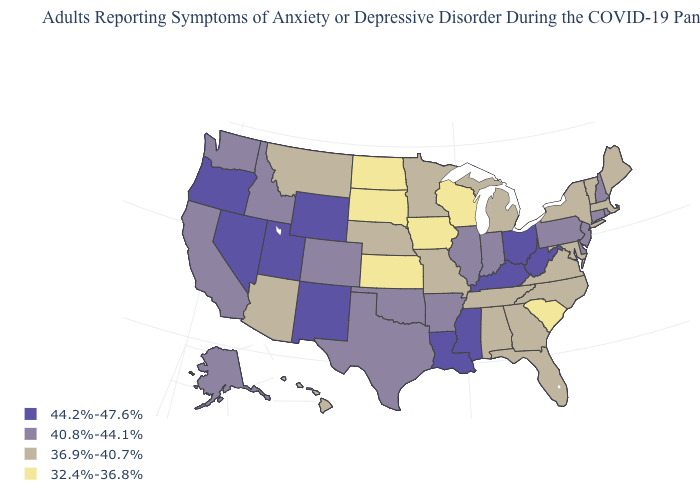Name the states that have a value in the range 32.4%-36.8%?
Give a very brief answer. Iowa, Kansas, North Dakota, South Carolina, South Dakota, Wisconsin. How many symbols are there in the legend?
Short answer required. 4. Among the states that border Minnesota , which have the lowest value?
Write a very short answer. Iowa, North Dakota, South Dakota, Wisconsin. How many symbols are there in the legend?
Answer briefly. 4. Name the states that have a value in the range 36.9%-40.7%?
Quick response, please. Alabama, Arizona, Florida, Georgia, Hawaii, Maine, Maryland, Massachusetts, Michigan, Minnesota, Missouri, Montana, Nebraska, New York, North Carolina, Tennessee, Vermont, Virginia. Name the states that have a value in the range 36.9%-40.7%?
Write a very short answer. Alabama, Arizona, Florida, Georgia, Hawaii, Maine, Maryland, Massachusetts, Michigan, Minnesota, Missouri, Montana, Nebraska, New York, North Carolina, Tennessee, Vermont, Virginia. Does Georgia have the lowest value in the South?
Be succinct. No. What is the highest value in the MidWest ?
Keep it brief. 44.2%-47.6%. What is the value of Hawaii?
Concise answer only. 36.9%-40.7%. Does Montana have the same value as Minnesota?
Quick response, please. Yes. What is the value of Florida?
Be succinct. 36.9%-40.7%. Does Maine have the lowest value in the Northeast?
Concise answer only. Yes. Name the states that have a value in the range 32.4%-36.8%?
Concise answer only. Iowa, Kansas, North Dakota, South Carolina, South Dakota, Wisconsin. Is the legend a continuous bar?
Concise answer only. No. What is the highest value in states that border North Carolina?
Short answer required. 36.9%-40.7%. 